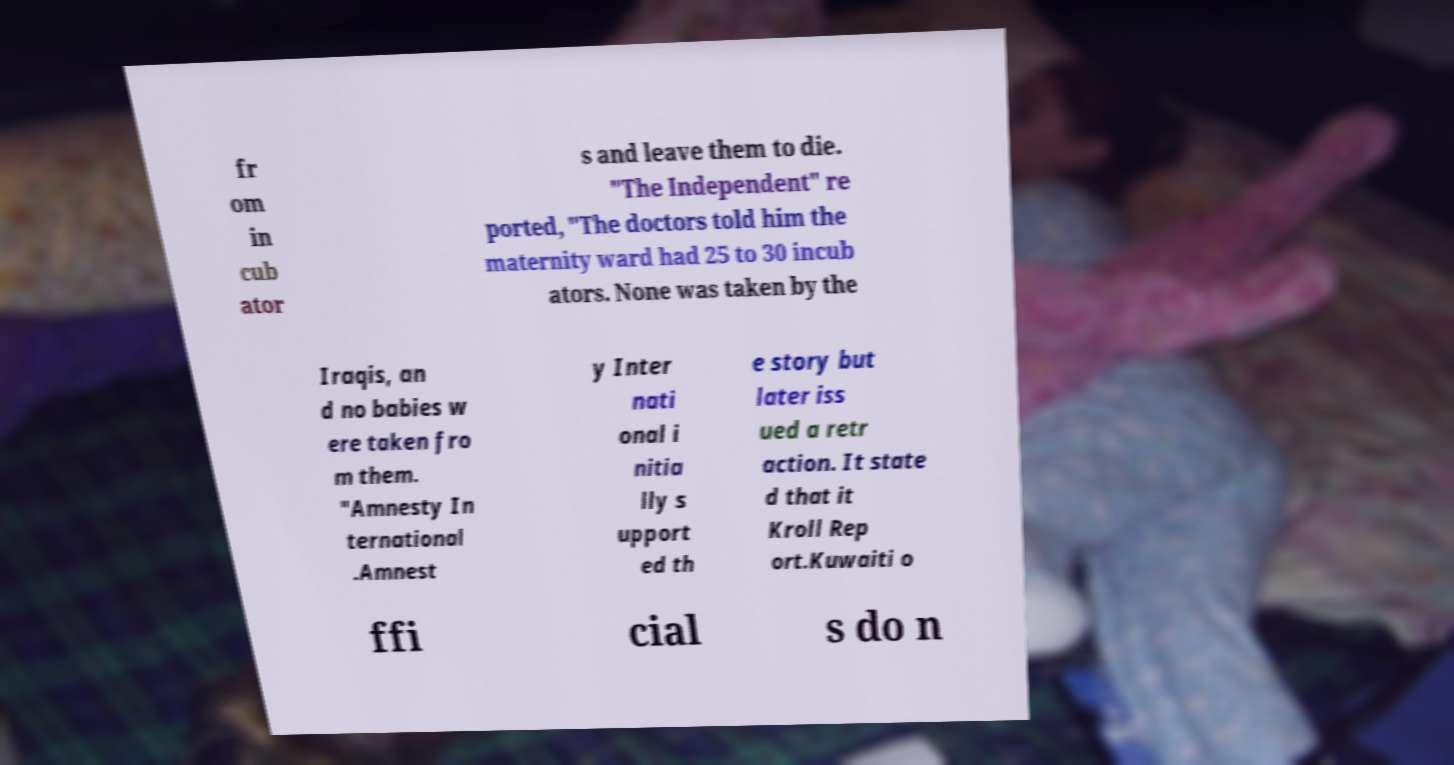What messages or text are displayed in this image? I need them in a readable, typed format. fr om in cub ator s and leave them to die. "The Independent" re ported, "The doctors told him the maternity ward had 25 to 30 incub ators. None was taken by the Iraqis, an d no babies w ere taken fro m them. "Amnesty In ternational .Amnest y Inter nati onal i nitia lly s upport ed th e story but later iss ued a retr action. It state d that it Kroll Rep ort.Kuwaiti o ffi cial s do n 